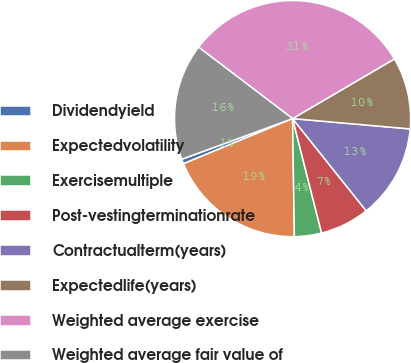Convert chart. <chart><loc_0><loc_0><loc_500><loc_500><pie_chart><fcel>Dividendyield<fcel>Expectedvolatility<fcel>Exercisemultiple<fcel>Post-vestingterminationrate<fcel>Contractualterm(years)<fcel>Expectedlife(years)<fcel>Weighted average exercise<fcel>Weighted average fair value of<nl><fcel>0.65%<fcel>19.0%<fcel>3.71%<fcel>6.77%<fcel>12.88%<fcel>9.83%<fcel>31.22%<fcel>15.94%<nl></chart> 